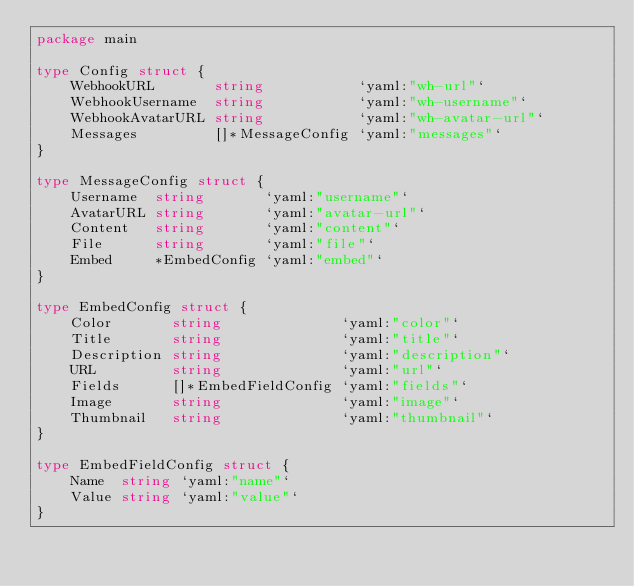<code> <loc_0><loc_0><loc_500><loc_500><_Go_>package main

type Config struct {
	WebhookURL       string           `yaml:"wh-url"`
	WebhookUsername  string           `yaml:"wh-username"`
	WebhookAvatarURL string           `yaml:"wh-avatar-url"`
	Messages         []*MessageConfig `yaml:"messages"`
}

type MessageConfig struct {
	Username  string       `yaml:"username"`
	AvatarURL string       `yaml:"avatar-url"`
	Content   string       `yaml:"content"`
	File      string       `yaml:"file"`
	Embed     *EmbedConfig `yaml:"embed"`
}

type EmbedConfig struct {
	Color       string              `yaml:"color"`
	Title       string              `yaml:"title"`
	Description string              `yaml:"description"`
	URL         string              `yaml:"url"`
	Fields      []*EmbedFieldConfig `yaml:"fields"`
	Image       string              `yaml:"image"`
	Thumbnail   string              `yaml:"thumbnail"`
}

type EmbedFieldConfig struct {
	Name  string `yaml:"name"`
	Value string `yaml:"value"`
}
</code> 